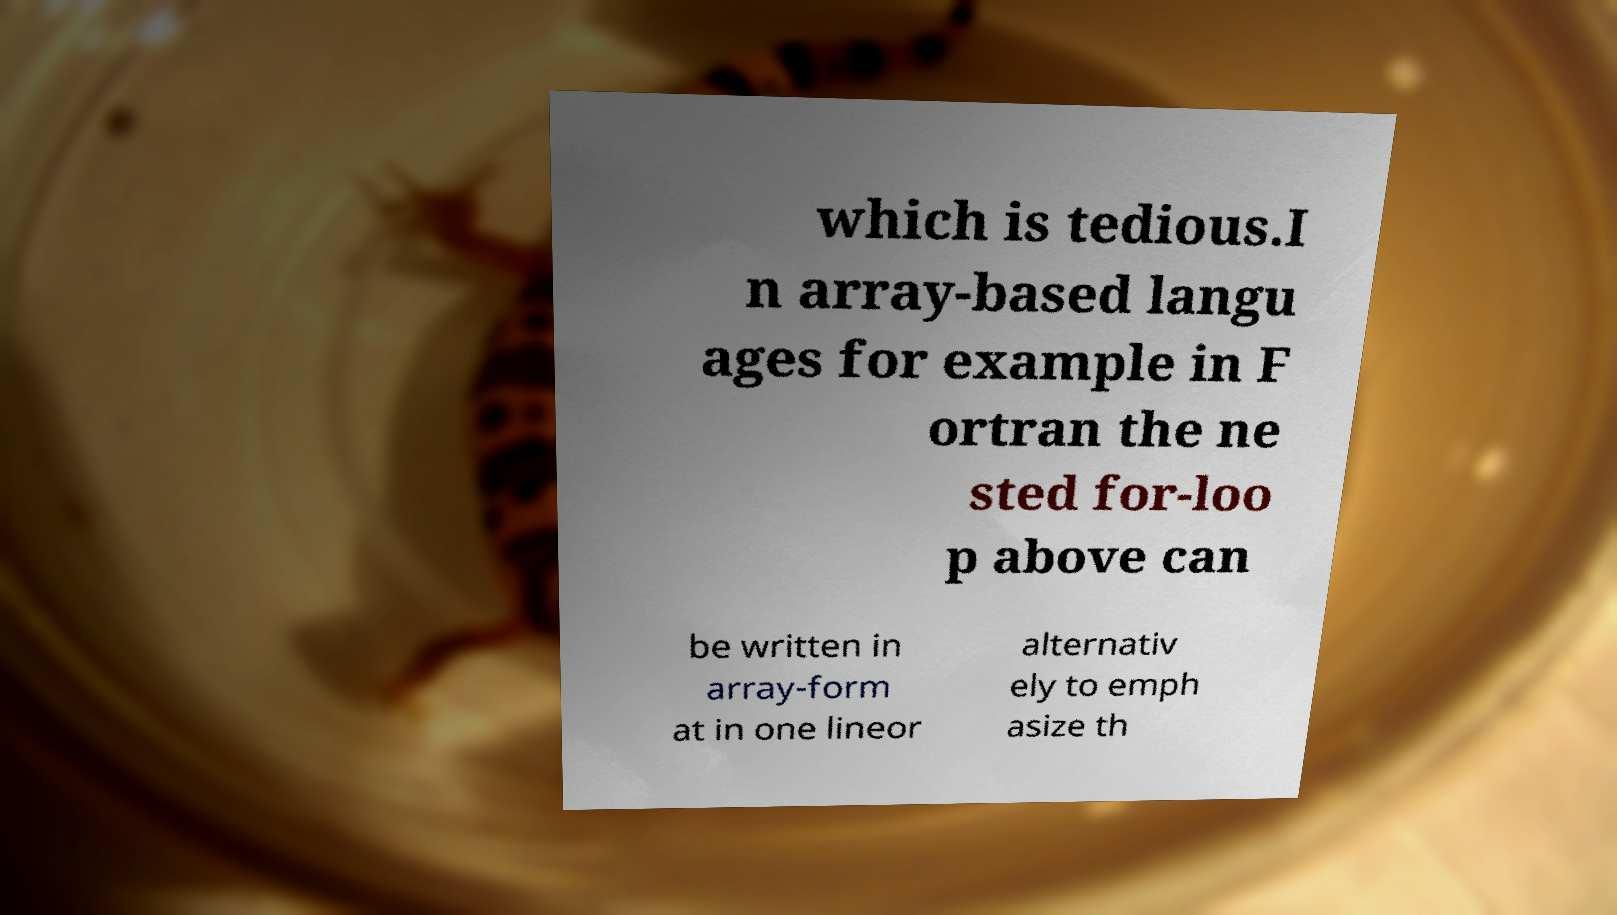Could you extract and type out the text from this image? which is tedious.I n array-based langu ages for example in F ortran the ne sted for-loo p above can be written in array-form at in one lineor alternativ ely to emph asize th 